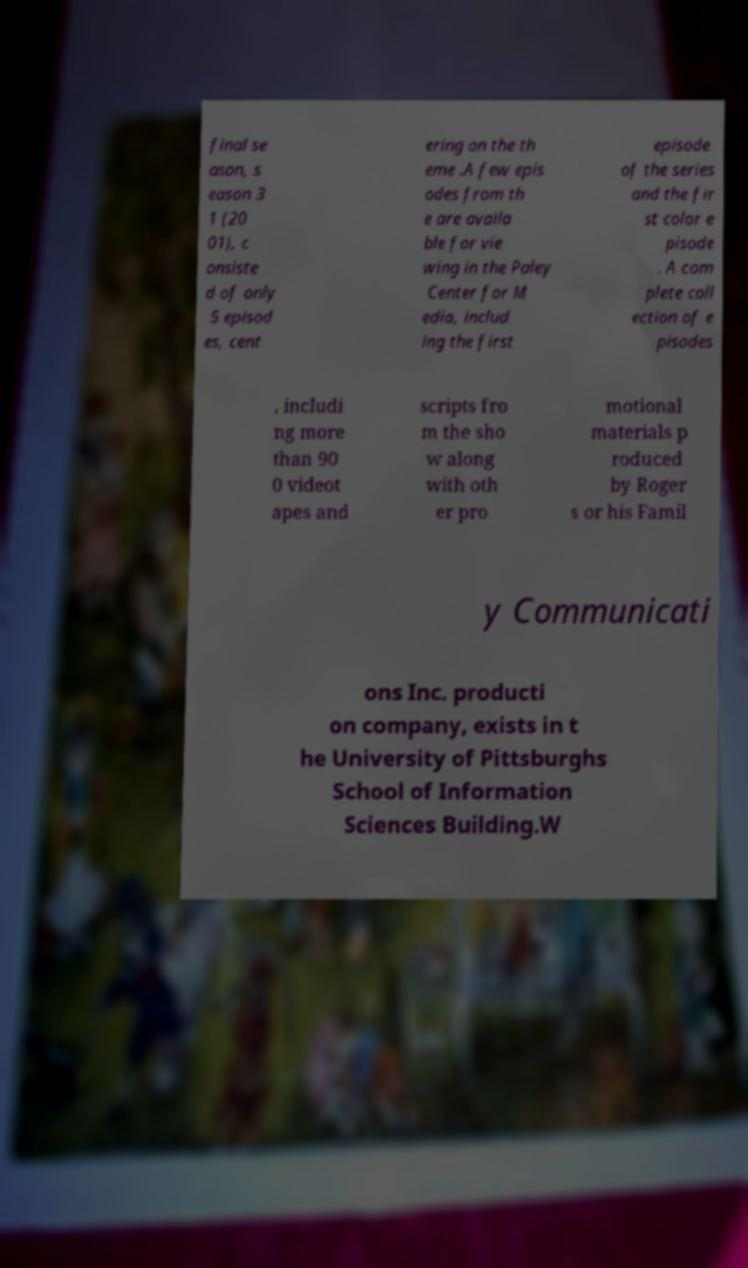For documentation purposes, I need the text within this image transcribed. Could you provide that? final se ason, s eason 3 1 (20 01), c onsiste d of only 5 episod es, cent ering on the th eme .A few epis odes from th e are availa ble for vie wing in the Paley Center for M edia, includ ing the first episode of the series and the fir st color e pisode . A com plete coll ection of e pisodes , includi ng more than 90 0 videot apes and scripts fro m the sho w along with oth er pro motional materials p roduced by Roger s or his Famil y Communicati ons Inc. producti on company, exists in t he University of Pittsburghs School of Information Sciences Building.W 